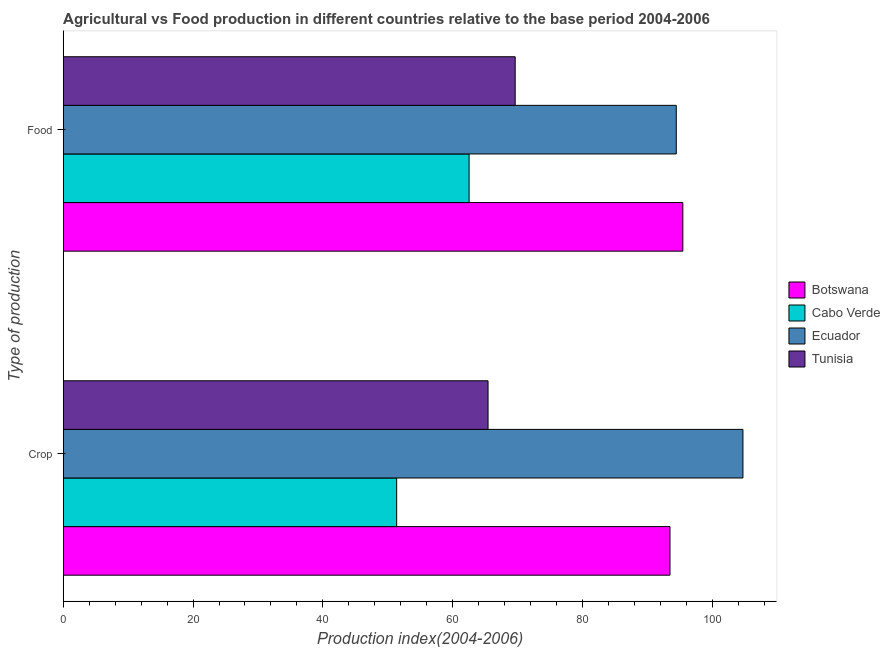How many groups of bars are there?
Your answer should be very brief. 2. Are the number of bars on each tick of the Y-axis equal?
Give a very brief answer. Yes. How many bars are there on the 2nd tick from the bottom?
Make the answer very short. 4. What is the label of the 2nd group of bars from the top?
Your response must be concise. Crop. What is the food production index in Tunisia?
Provide a succinct answer. 69.63. Across all countries, what is the maximum crop production index?
Provide a short and direct response. 104.72. Across all countries, what is the minimum food production index?
Provide a succinct answer. 62.53. In which country was the food production index maximum?
Your answer should be very brief. Botswana. In which country was the crop production index minimum?
Ensure brevity in your answer.  Cabo Verde. What is the total crop production index in the graph?
Offer a terse response. 315.02. What is the difference between the crop production index in Cabo Verde and that in Ecuador?
Offer a terse response. -53.35. What is the difference between the crop production index in Botswana and the food production index in Ecuador?
Offer a terse response. -0.97. What is the average crop production index per country?
Provide a short and direct response. 78.75. What is the difference between the food production index and crop production index in Ecuador?
Your answer should be compact. -10.27. In how many countries, is the food production index greater than 104 ?
Your answer should be very brief. 0. What is the ratio of the food production index in Botswana to that in Tunisia?
Keep it short and to the point. 1.37. In how many countries, is the crop production index greater than the average crop production index taken over all countries?
Your answer should be very brief. 2. What does the 3rd bar from the top in Crop represents?
Make the answer very short. Cabo Verde. What does the 4th bar from the bottom in Crop represents?
Make the answer very short. Tunisia. How many bars are there?
Your answer should be compact. 8. Are all the bars in the graph horizontal?
Your answer should be very brief. Yes. How many countries are there in the graph?
Provide a succinct answer. 4. Are the values on the major ticks of X-axis written in scientific E-notation?
Keep it short and to the point. No. Does the graph contain any zero values?
Offer a very short reply. No. Does the graph contain grids?
Provide a succinct answer. No. Where does the legend appear in the graph?
Offer a terse response. Center right. What is the title of the graph?
Make the answer very short. Agricultural vs Food production in different countries relative to the base period 2004-2006. Does "Guyana" appear as one of the legend labels in the graph?
Offer a terse response. No. What is the label or title of the X-axis?
Give a very brief answer. Production index(2004-2006). What is the label or title of the Y-axis?
Your answer should be compact. Type of production. What is the Production index(2004-2006) in Botswana in Crop?
Your answer should be very brief. 93.48. What is the Production index(2004-2006) in Cabo Verde in Crop?
Offer a terse response. 51.37. What is the Production index(2004-2006) of Ecuador in Crop?
Keep it short and to the point. 104.72. What is the Production index(2004-2006) in Tunisia in Crop?
Keep it short and to the point. 65.45. What is the Production index(2004-2006) of Botswana in Food?
Offer a terse response. 95.46. What is the Production index(2004-2006) of Cabo Verde in Food?
Offer a very short reply. 62.53. What is the Production index(2004-2006) in Ecuador in Food?
Provide a short and direct response. 94.45. What is the Production index(2004-2006) in Tunisia in Food?
Give a very brief answer. 69.63. Across all Type of production, what is the maximum Production index(2004-2006) of Botswana?
Your answer should be compact. 95.46. Across all Type of production, what is the maximum Production index(2004-2006) of Cabo Verde?
Give a very brief answer. 62.53. Across all Type of production, what is the maximum Production index(2004-2006) in Ecuador?
Keep it short and to the point. 104.72. Across all Type of production, what is the maximum Production index(2004-2006) of Tunisia?
Ensure brevity in your answer.  69.63. Across all Type of production, what is the minimum Production index(2004-2006) in Botswana?
Make the answer very short. 93.48. Across all Type of production, what is the minimum Production index(2004-2006) of Cabo Verde?
Provide a short and direct response. 51.37. Across all Type of production, what is the minimum Production index(2004-2006) in Ecuador?
Your response must be concise. 94.45. Across all Type of production, what is the minimum Production index(2004-2006) of Tunisia?
Offer a terse response. 65.45. What is the total Production index(2004-2006) of Botswana in the graph?
Provide a succinct answer. 188.94. What is the total Production index(2004-2006) of Cabo Verde in the graph?
Your answer should be very brief. 113.9. What is the total Production index(2004-2006) of Ecuador in the graph?
Your answer should be very brief. 199.17. What is the total Production index(2004-2006) in Tunisia in the graph?
Make the answer very short. 135.08. What is the difference between the Production index(2004-2006) of Botswana in Crop and that in Food?
Make the answer very short. -1.98. What is the difference between the Production index(2004-2006) of Cabo Verde in Crop and that in Food?
Make the answer very short. -11.16. What is the difference between the Production index(2004-2006) in Ecuador in Crop and that in Food?
Your response must be concise. 10.27. What is the difference between the Production index(2004-2006) of Tunisia in Crop and that in Food?
Make the answer very short. -4.18. What is the difference between the Production index(2004-2006) in Botswana in Crop and the Production index(2004-2006) in Cabo Verde in Food?
Offer a very short reply. 30.95. What is the difference between the Production index(2004-2006) in Botswana in Crop and the Production index(2004-2006) in Ecuador in Food?
Offer a terse response. -0.97. What is the difference between the Production index(2004-2006) in Botswana in Crop and the Production index(2004-2006) in Tunisia in Food?
Make the answer very short. 23.85. What is the difference between the Production index(2004-2006) in Cabo Verde in Crop and the Production index(2004-2006) in Ecuador in Food?
Provide a short and direct response. -43.08. What is the difference between the Production index(2004-2006) of Cabo Verde in Crop and the Production index(2004-2006) of Tunisia in Food?
Give a very brief answer. -18.26. What is the difference between the Production index(2004-2006) in Ecuador in Crop and the Production index(2004-2006) in Tunisia in Food?
Give a very brief answer. 35.09. What is the average Production index(2004-2006) of Botswana per Type of production?
Offer a very short reply. 94.47. What is the average Production index(2004-2006) in Cabo Verde per Type of production?
Offer a terse response. 56.95. What is the average Production index(2004-2006) of Ecuador per Type of production?
Your answer should be very brief. 99.58. What is the average Production index(2004-2006) in Tunisia per Type of production?
Provide a succinct answer. 67.54. What is the difference between the Production index(2004-2006) of Botswana and Production index(2004-2006) of Cabo Verde in Crop?
Make the answer very short. 42.11. What is the difference between the Production index(2004-2006) of Botswana and Production index(2004-2006) of Ecuador in Crop?
Ensure brevity in your answer.  -11.24. What is the difference between the Production index(2004-2006) in Botswana and Production index(2004-2006) in Tunisia in Crop?
Your answer should be compact. 28.03. What is the difference between the Production index(2004-2006) of Cabo Verde and Production index(2004-2006) of Ecuador in Crop?
Offer a terse response. -53.35. What is the difference between the Production index(2004-2006) of Cabo Verde and Production index(2004-2006) of Tunisia in Crop?
Offer a terse response. -14.08. What is the difference between the Production index(2004-2006) of Ecuador and Production index(2004-2006) of Tunisia in Crop?
Offer a very short reply. 39.27. What is the difference between the Production index(2004-2006) in Botswana and Production index(2004-2006) in Cabo Verde in Food?
Your response must be concise. 32.93. What is the difference between the Production index(2004-2006) in Botswana and Production index(2004-2006) in Tunisia in Food?
Offer a very short reply. 25.83. What is the difference between the Production index(2004-2006) in Cabo Verde and Production index(2004-2006) in Ecuador in Food?
Provide a succinct answer. -31.92. What is the difference between the Production index(2004-2006) in Cabo Verde and Production index(2004-2006) in Tunisia in Food?
Your answer should be very brief. -7.1. What is the difference between the Production index(2004-2006) of Ecuador and Production index(2004-2006) of Tunisia in Food?
Your answer should be compact. 24.82. What is the ratio of the Production index(2004-2006) of Botswana in Crop to that in Food?
Give a very brief answer. 0.98. What is the ratio of the Production index(2004-2006) of Cabo Verde in Crop to that in Food?
Make the answer very short. 0.82. What is the ratio of the Production index(2004-2006) in Ecuador in Crop to that in Food?
Ensure brevity in your answer.  1.11. What is the difference between the highest and the second highest Production index(2004-2006) in Botswana?
Your response must be concise. 1.98. What is the difference between the highest and the second highest Production index(2004-2006) of Cabo Verde?
Your answer should be very brief. 11.16. What is the difference between the highest and the second highest Production index(2004-2006) of Ecuador?
Give a very brief answer. 10.27. What is the difference between the highest and the second highest Production index(2004-2006) of Tunisia?
Offer a terse response. 4.18. What is the difference between the highest and the lowest Production index(2004-2006) in Botswana?
Give a very brief answer. 1.98. What is the difference between the highest and the lowest Production index(2004-2006) of Cabo Verde?
Make the answer very short. 11.16. What is the difference between the highest and the lowest Production index(2004-2006) of Ecuador?
Provide a short and direct response. 10.27. What is the difference between the highest and the lowest Production index(2004-2006) of Tunisia?
Provide a short and direct response. 4.18. 